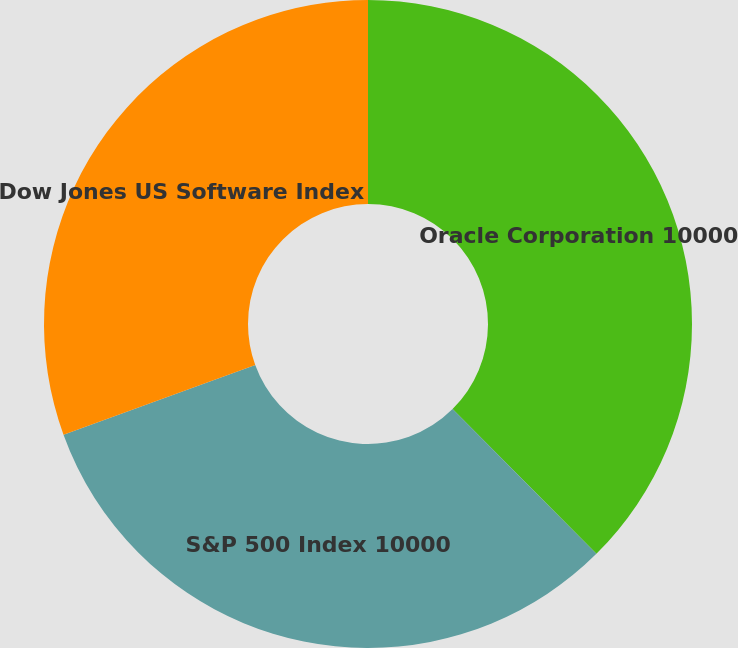<chart> <loc_0><loc_0><loc_500><loc_500><pie_chart><fcel>Oracle Corporation 10000<fcel>S&P 500 Index 10000<fcel>Dow Jones US Software Index<nl><fcel>37.55%<fcel>31.9%<fcel>30.55%<nl></chart> 